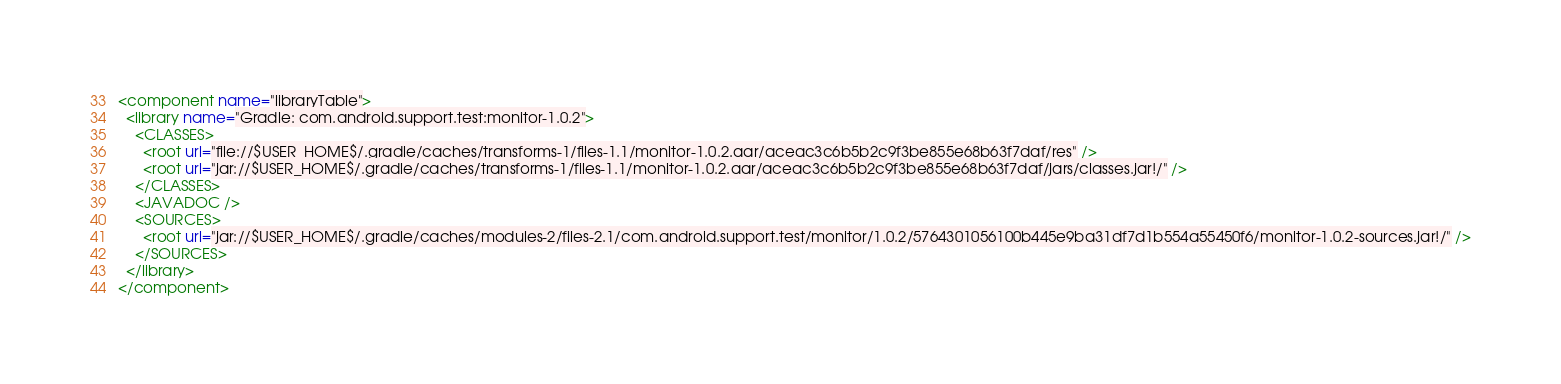Convert code to text. <code><loc_0><loc_0><loc_500><loc_500><_XML_><component name="libraryTable">
  <library name="Gradle: com.android.support.test:monitor-1.0.2">
    <CLASSES>
      <root url="file://$USER_HOME$/.gradle/caches/transforms-1/files-1.1/monitor-1.0.2.aar/aceac3c6b5b2c9f3be855e68b63f7daf/res" />
      <root url="jar://$USER_HOME$/.gradle/caches/transforms-1/files-1.1/monitor-1.0.2.aar/aceac3c6b5b2c9f3be855e68b63f7daf/jars/classes.jar!/" />
    </CLASSES>
    <JAVADOC />
    <SOURCES>
      <root url="jar://$USER_HOME$/.gradle/caches/modules-2/files-2.1/com.android.support.test/monitor/1.0.2/5764301056100b445e9ba31df7d1b554a55450f6/monitor-1.0.2-sources.jar!/" />
    </SOURCES>
  </library>
</component></code> 